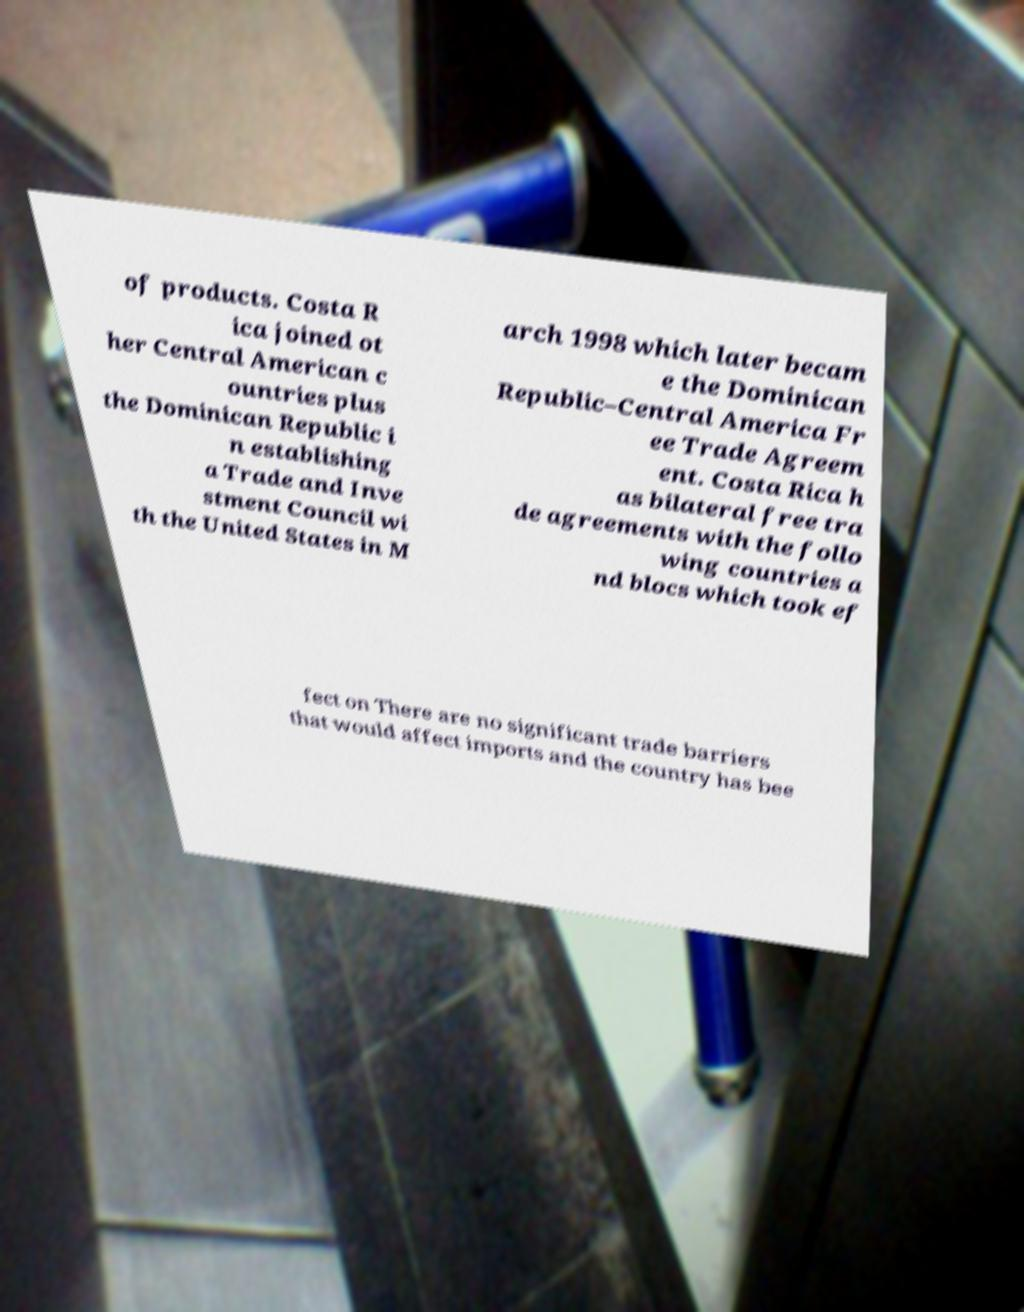Please read and relay the text visible in this image. What does it say? of products. Costa R ica joined ot her Central American c ountries plus the Dominican Republic i n establishing a Trade and Inve stment Council wi th the United States in M arch 1998 which later becam e the Dominican Republic–Central America Fr ee Trade Agreem ent. Costa Rica h as bilateral free tra de agreements with the follo wing countries a nd blocs which took ef fect on There are no significant trade barriers that would affect imports and the country has bee 